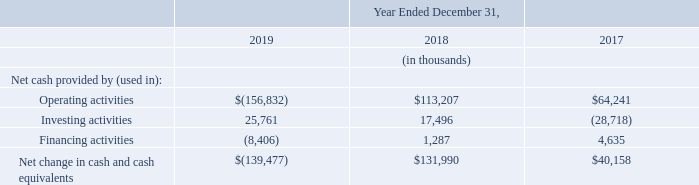Cash Flows
The following table summarizes our cash flows for the periods indicated:
Cash Flows from Operating Activities
Net cash used in operating activities of $156.8 million in 2019 was primarily due to a net loss of $320.7 million, as well as an increase in net operating assets and liabilities of $3.3 million, partially offset by total non-cash adjustments of $167.2 million. The increase in net operating assets and liabilities included a $21.3 million increase in accounts receivable primarily due to an increase in days sales outstanding, an $18.5 million increase in inventories primarily due to Fitbit Versa Lite Edition, Fitbit Inspire, Fitbit Inspire HR and Fitbit Versa 2, and a $22.9 million decrease in lease liabilities, partially offset by a $40.7 million net increase in accounts payable and accrued liabilities and other liabilities primarily related to higher rebates and promotional activities in the fourth quarter of 2019, a $15.1 million decrease in prepaid expenses and other assets, and a $4.0 million increase in deferred revenue. Our days sales outstanding in accounts receivable, calculated as the number of days represented by the accounts receivable balance as of period end, increased from 70 days as of December 31, 2018 to 74 days as of December 31, 2019, due to lower collections during the fourth quarter of 2019 compared to the fourth quarter of 2018. The $167.2 million total non-cash adjustments for 2019 included stock-based compensation expense of $77.7 million, depreciation and amortization expense of $62.8 million, and non-cash lease expense of $19.2 million.
Net cash used in operating activities was $156.8 million in 2019, compared to net cash provided by operating activities of $113.2 million in 2018, primarily due to a $134.9 million increase in net loss for 2019 compared to 2018, an increase of $126.0 million in change in net operating assets and liabilities compared to 2018 primarily related to a $72.2 million income tax refund received in 2018 and increases in accounts receivable and inventories in 2019, as well as a decrease of $9.1 million for non-cash adjustments to net loss in 2019 compared to 2018.
Cash Flows from Investing Activities
Net cash provided by investing activities for 2019 of $25.8 million was primarily due to maturities and sales of marketable securities of $414.7 million, partially offset by purchases of marketable securities of $347.6 million, purchases of property and equipment of $36.5 million, payment of $2.2 million for the cash portion of an acquisition, net of cash acquired, and acquisition-related holdback payments of $2.6 million.
Net cash provided by investing activities for 2018 of $17.5 million was primarily due to maturities and sales of marketable securities of $443.6 million, partially offset by purchases of marketable securities of $353.9 million, purchases of property and equipment of $52.9 million, payment of $13.6 million for the cash portion of an acquisition, net of cash acquired, and acquisition-related holdback payments of $5.6 million.
We may continue to use cash in the future to acquire businesses and technologies that enhance and expand our product offerings. Due to the nature of these transactions, it is difficult to predict the amount and timing of such cash requirements to complete such transactions. We may be required to raise additional funds to complete future acquisitions.
Cash Flows from Financing Activities
Net cash used in financing activities for 2019 of $8.4 million was primarily due to $18.2 million in net cash used for payment of taxes on common stock issued under our employee equity incentive plans and $2.7 million used for financing lease payments, offset in part by $13.0 million in proceeds from the exercise of stock options and from stock purchases made through our 2015 Employee Stock Purchase Plan, or 2015 ESPP.
Why did the days sales outstanding in accounts receivable increased from 70 days to 74 days between 2018 and 2019? Due to lower collections during the fourth quarter of 2019 compared to the fourth quarter of 2018. What factors led to net cash used in operating activities of $156.8 million in 2019? Due to a net loss of $320.7 million, as well as an increase in net operating assets and liabilities of $3.3 million, partially offset by total non-cash adjustments of $167.2 million. What was the net cash used in financing activities for 2019? $8.4 million. What was the difference in net cash provided by operating activities between 2017 and 2018?
Answer scale should be: thousand. 113,207-64,241
Answer: 48966. What was the percentage change for the total net change in cash and cash equivalents from 2017 to 2018?
Answer scale should be: percent. (131,990-40,158)/40,158
Answer: 228.68. What is the average net cash provided by investing activities for 2018 and 2019?
Answer scale should be: thousand. (25,761+17,496)/2
Answer: 21628.5. 